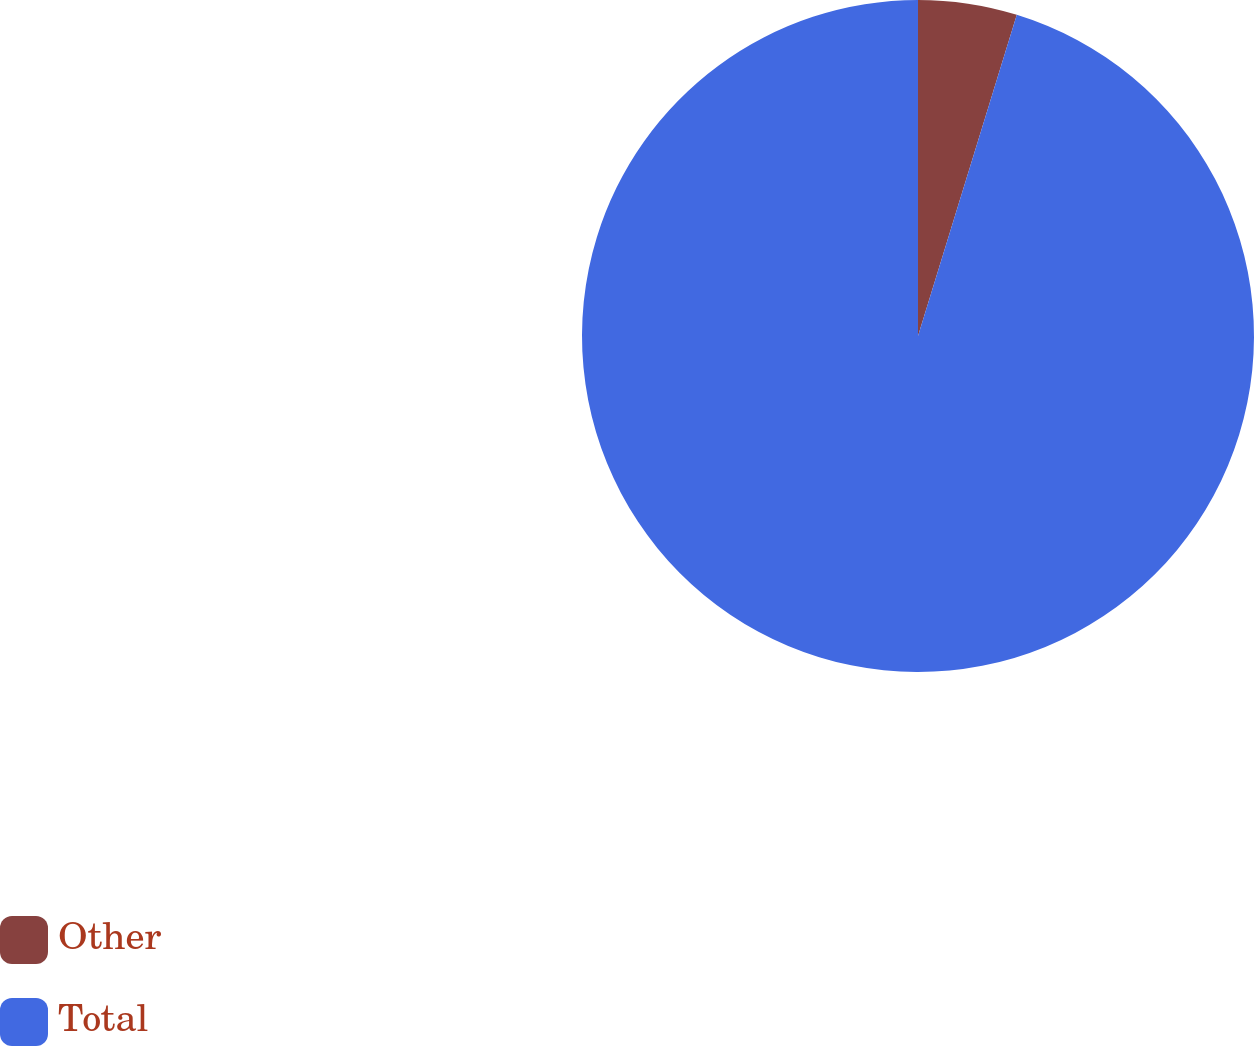Convert chart. <chart><loc_0><loc_0><loc_500><loc_500><pie_chart><fcel>Other<fcel>Total<nl><fcel>4.75%<fcel>95.25%<nl></chart> 